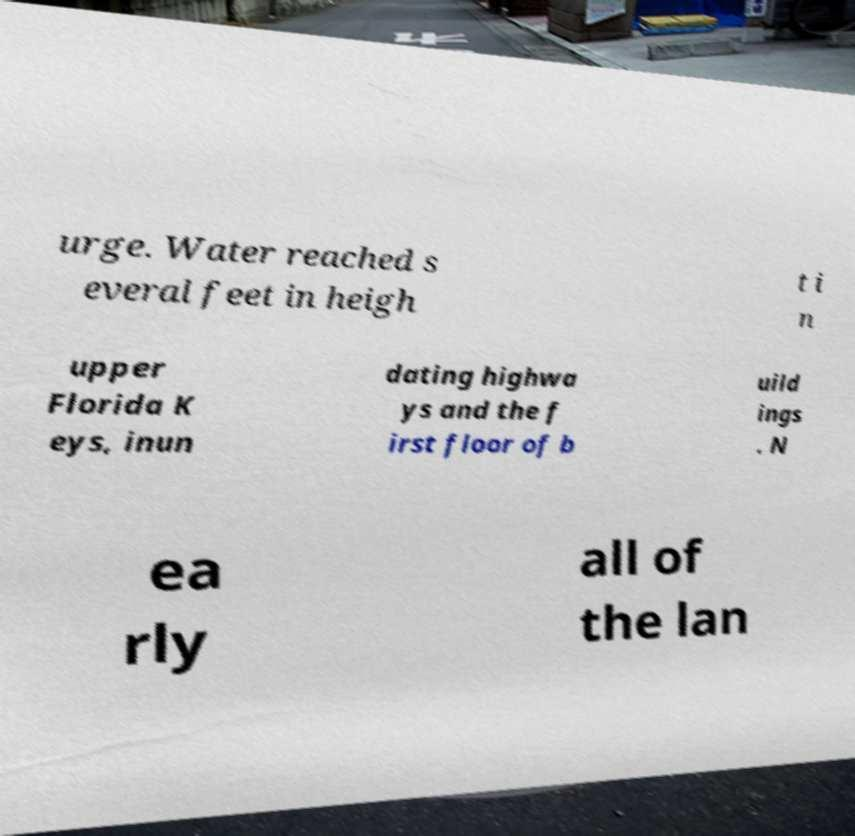For documentation purposes, I need the text within this image transcribed. Could you provide that? urge. Water reached s everal feet in heigh t i n upper Florida K eys, inun dating highwa ys and the f irst floor of b uild ings . N ea rly all of the lan 